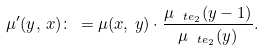Convert formula to latex. <formula><loc_0><loc_0><loc_500><loc_500>\mu ^ { \prime } ( y , \, x ) \colon \, = \mu ( x , \, y ) \cdot \frac { \mu _ { \ t e _ { 2 } } ( y - 1 ) } { \mu _ { \ t e _ { 2 } } ( y ) } .</formula> 